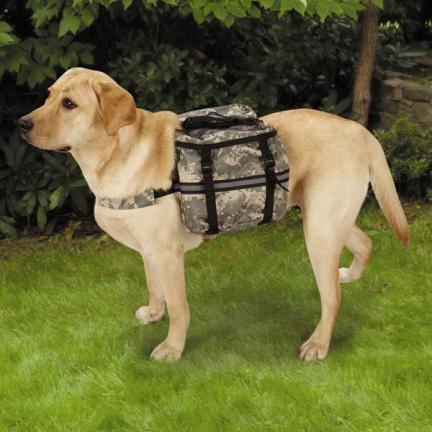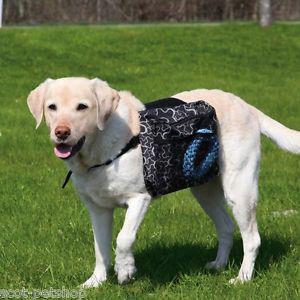The first image is the image on the left, the second image is the image on the right. For the images displayed, is the sentence "The combined images include two standing dogs, with at least one of them wearing a collar but no pack." factually correct? Answer yes or no. No. The first image is the image on the left, the second image is the image on the right. For the images shown, is this caption "The left image contains exactly two dogs." true? Answer yes or no. No. 